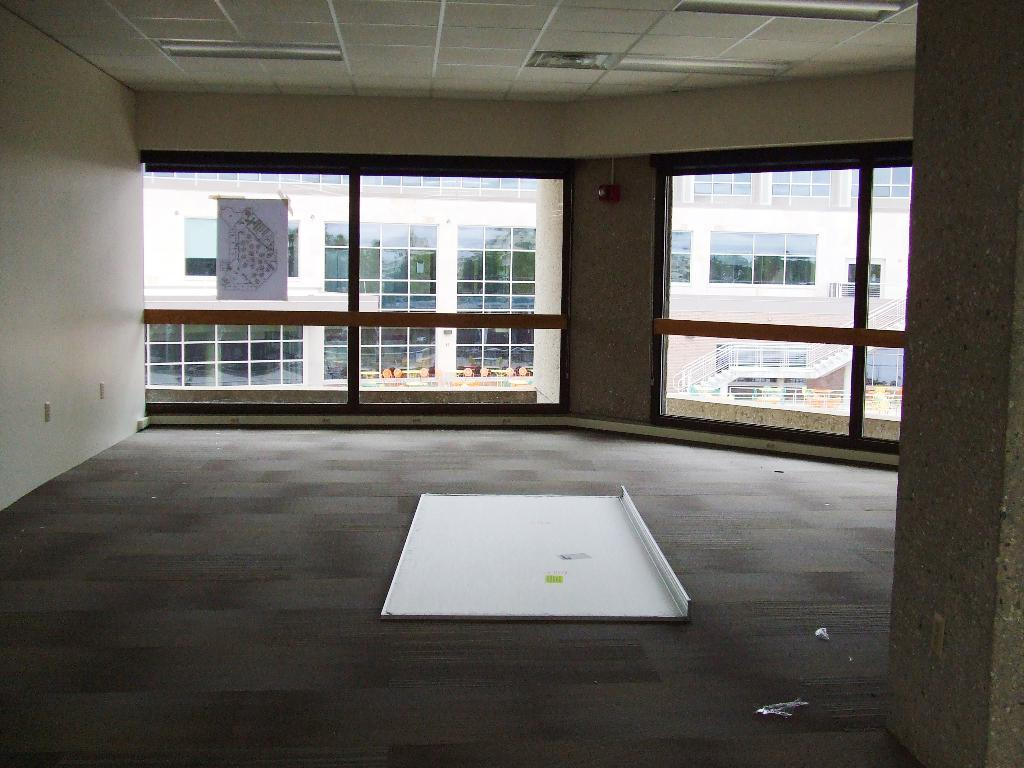What is the general setting of the image? The image depicts a spacious area. What can be seen in the background of the image? There are windows in the background of the image. What is visible through the windows? A huge building is visible behind the windows. What type of loaf is being served at the table in the image? There is no table or loaf present in the image; it features a spacious area with windows and a huge building in the background. 